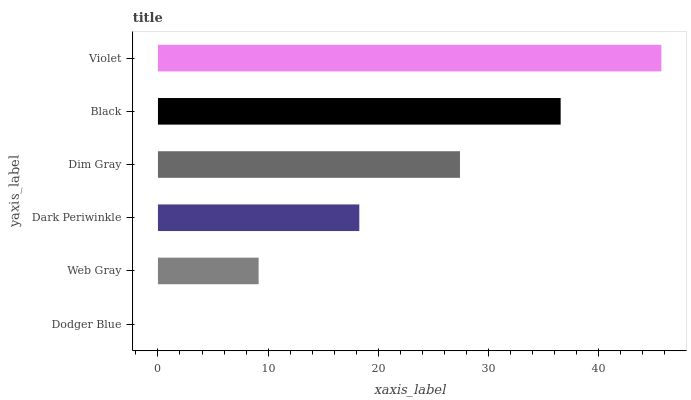Is Dodger Blue the minimum?
Answer yes or no. Yes. Is Violet the maximum?
Answer yes or no. Yes. Is Web Gray the minimum?
Answer yes or no. No. Is Web Gray the maximum?
Answer yes or no. No. Is Web Gray greater than Dodger Blue?
Answer yes or no. Yes. Is Dodger Blue less than Web Gray?
Answer yes or no. Yes. Is Dodger Blue greater than Web Gray?
Answer yes or no. No. Is Web Gray less than Dodger Blue?
Answer yes or no. No. Is Dim Gray the high median?
Answer yes or no. Yes. Is Dark Periwinkle the low median?
Answer yes or no. Yes. Is Dark Periwinkle the high median?
Answer yes or no. No. Is Web Gray the low median?
Answer yes or no. No. 